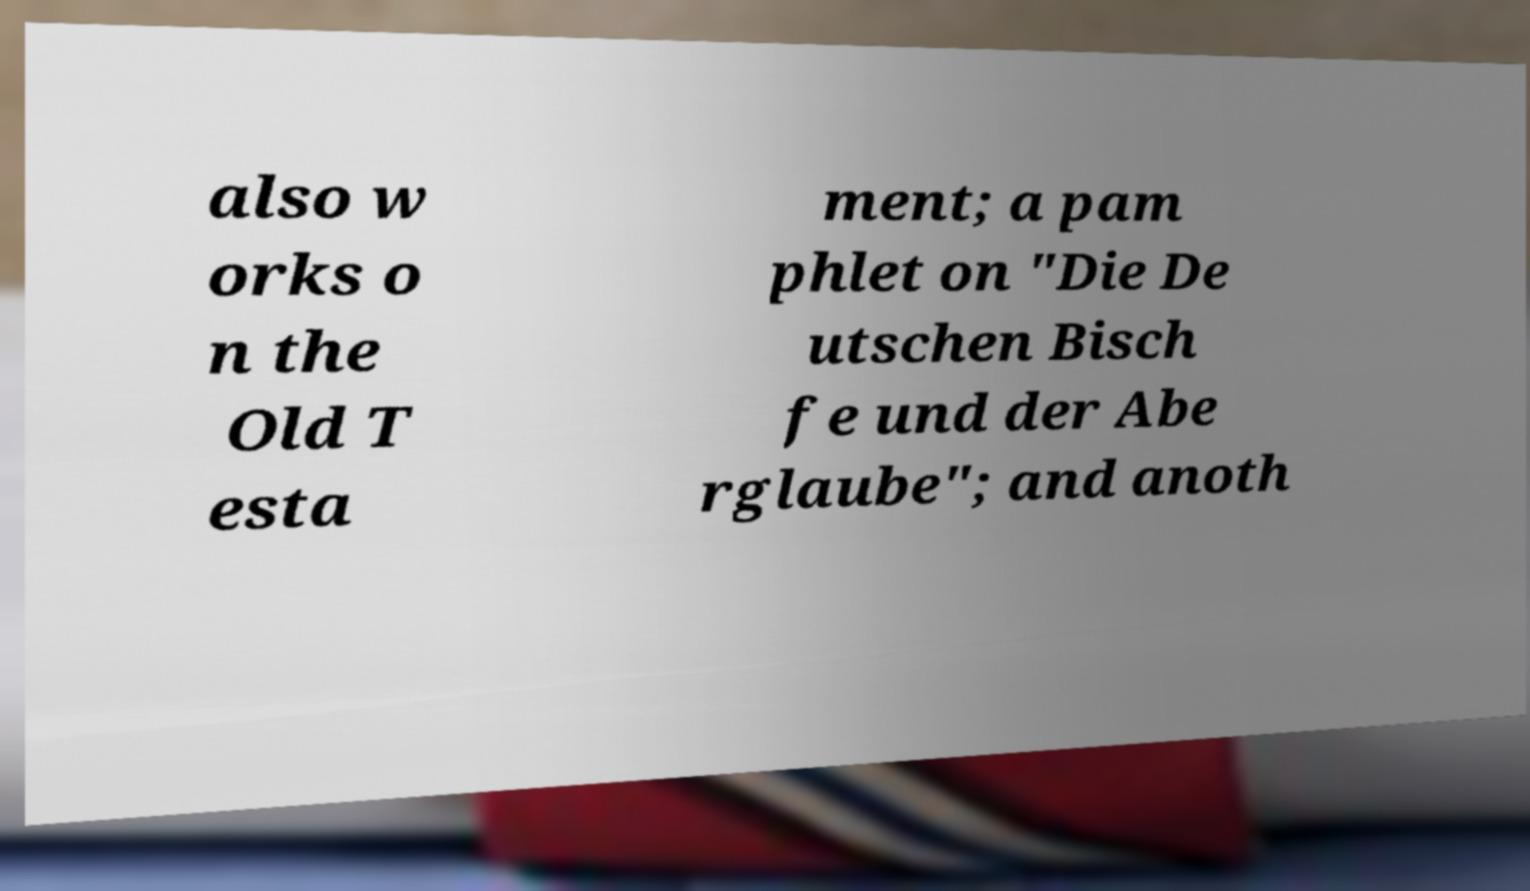Please read and relay the text visible in this image. What does it say? also w orks o n the Old T esta ment; a pam phlet on "Die De utschen Bisch fe und der Abe rglaube"; and anoth 